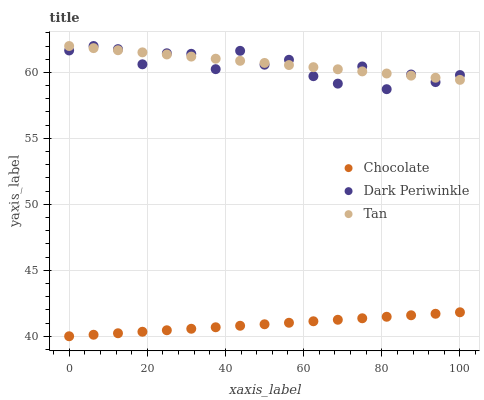Does Chocolate have the minimum area under the curve?
Answer yes or no. Yes. Does Tan have the maximum area under the curve?
Answer yes or no. Yes. Does Dark Periwinkle have the minimum area under the curve?
Answer yes or no. No. Does Dark Periwinkle have the maximum area under the curve?
Answer yes or no. No. Is Tan the smoothest?
Answer yes or no. Yes. Is Dark Periwinkle the roughest?
Answer yes or no. Yes. Is Chocolate the smoothest?
Answer yes or no. No. Is Chocolate the roughest?
Answer yes or no. No. Does Chocolate have the lowest value?
Answer yes or no. Yes. Does Dark Periwinkle have the lowest value?
Answer yes or no. No. Does Dark Periwinkle have the highest value?
Answer yes or no. Yes. Does Chocolate have the highest value?
Answer yes or no. No. Is Chocolate less than Tan?
Answer yes or no. Yes. Is Tan greater than Chocolate?
Answer yes or no. Yes. Does Dark Periwinkle intersect Tan?
Answer yes or no. Yes. Is Dark Periwinkle less than Tan?
Answer yes or no. No. Is Dark Periwinkle greater than Tan?
Answer yes or no. No. Does Chocolate intersect Tan?
Answer yes or no. No. 